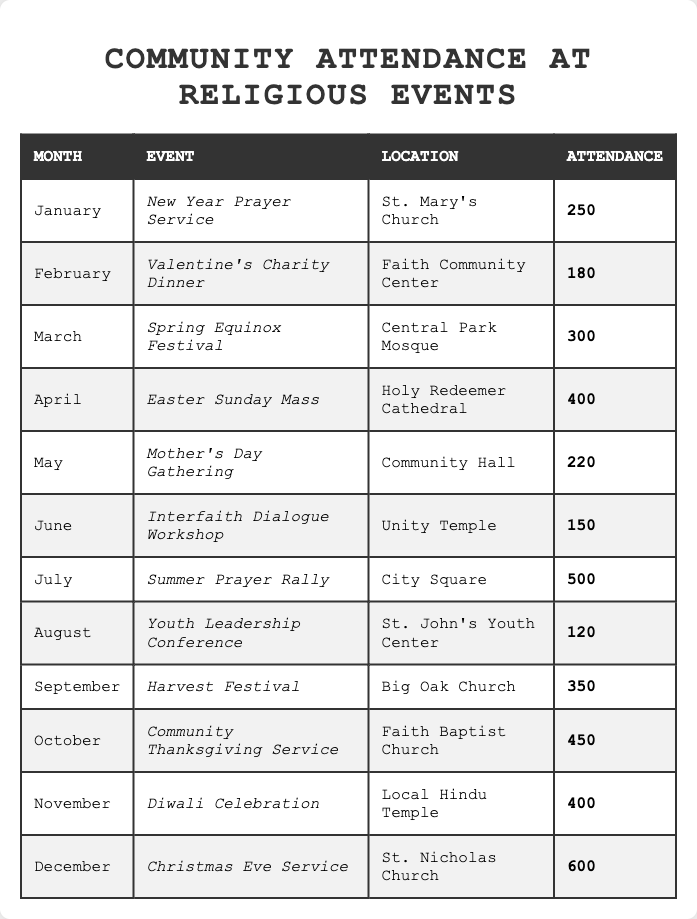What was the attendance for the Easter Sunday Mass in April? The table shows that the Easter Sunday Mass was held in April with an attendance of 400 people.
Answer: 400 Which month had the highest attendance at a religious event? By reviewing the attendance figures, December had the highest attendance with 600 people at the Christmas Eve Service.
Answer: 600 How many events had an attendance of more than 300? The events in March, April, July, September, October, November, and December had attendance figures of 300 and above, totaling 7 events.
Answer: 7 What was the attendance difference between the Summer Prayer Rally in July and the Christmas Eve Service in December? The Summer Prayer Rally had an attendance of 500, while the Christmas Eve Service had 600. The difference is 600 - 500 = 100.
Answer: 100 Was the attendance at the Diwali Celebration in November greater than that at the Valentine's Charity Dinner in February? The Diwali Celebration had an attendance of 400, while the Valentine's Charity Dinner had an attendance of 180. Thus, 400 is greater than 180, so the statement is true.
Answer: Yes What is the average attendance for the events held from January to June? The attendance numbers from January to June are 250, 180, 300, 400, 220, and 150. Summing these gives 250 + 180 + 300 + 400 + 220 + 150 = 1500. To find the average, divide by the number of events, which is 6: 1500/6 = 250.
Answer: 250 Which two months had the least attendance for their respective events? The table shows that August had the least attendance with 120 at the Youth Leadership Conference, and June had 150 at the Interfaith Dialogue Workshop. Therefore, August and June had the lowest attendance figures.
Answer: August and June What is the total attendance for all events in the second half of the year (July to December)? The attendance figures for the second half are 500 (July), 120 (August), 350 (September), 450 (October), 400 (November), and 600 (December). Adding these gives 500 + 120 + 350 + 450 + 400 + 600 = 2420.
Answer: 2420 How many events took place in locations other than a church? From the table, the Interfaith Dialogue Workshop in Unity Temple and the Youth Leadership Conference in St. John's Youth Center were not held in churches, totaling 2 events.
Answer: 2 What percentage of the total attendance for the year was for the Thanksgiving Service in October? The Thanksgiving Service had an attendance of 450. First, we’ll find the total attendance: 250 + 180 + 300 + 400 + 220 + 150 + 500 + 120 + 350 + 450 + 400 + 600 = 3050. The percentage is (450 / 3050) * 100 = approximately 14.75%.
Answer: 14.75% 